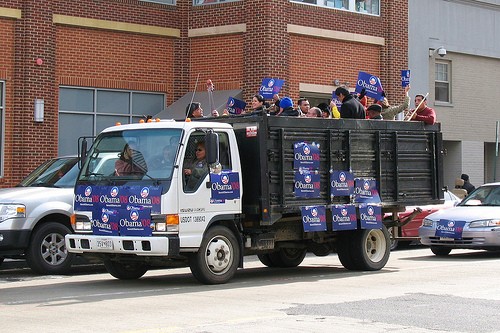Please provide a short description for this region: [0.83, 0.53, 1.0, 0.68]. A white vehicle is parked with a poster displayed prominently on its front. 